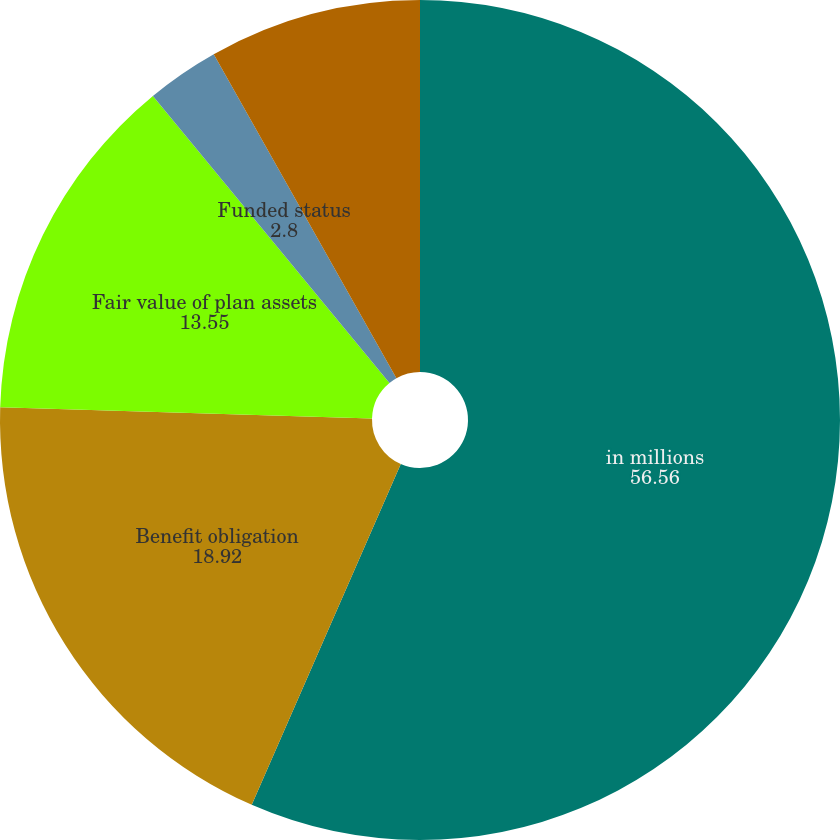Convert chart to OTSL. <chart><loc_0><loc_0><loc_500><loc_500><pie_chart><fcel>in millions<fcel>Benefit obligation<fcel>Fair value of plan assets<fcel>Funded status<fcel>Accrued compensation and<nl><fcel>56.56%<fcel>18.92%<fcel>13.55%<fcel>2.8%<fcel>8.17%<nl></chart> 